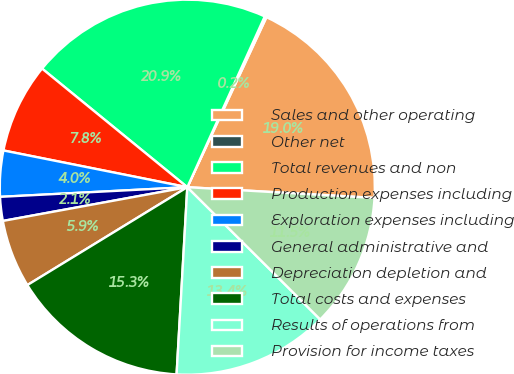Convert chart. <chart><loc_0><loc_0><loc_500><loc_500><pie_chart><fcel>Sales and other operating<fcel>Other net<fcel>Total revenues and non<fcel>Production expenses including<fcel>Exploration expenses including<fcel>General administrative and<fcel>Depreciation depletion and<fcel>Total costs and expenses<fcel>Results of operations from<fcel>Provision for income taxes<nl><fcel>18.98%<fcel>0.16%<fcel>20.88%<fcel>7.76%<fcel>3.96%<fcel>2.06%<fcel>5.86%<fcel>15.35%<fcel>13.45%<fcel>11.55%<nl></chart> 